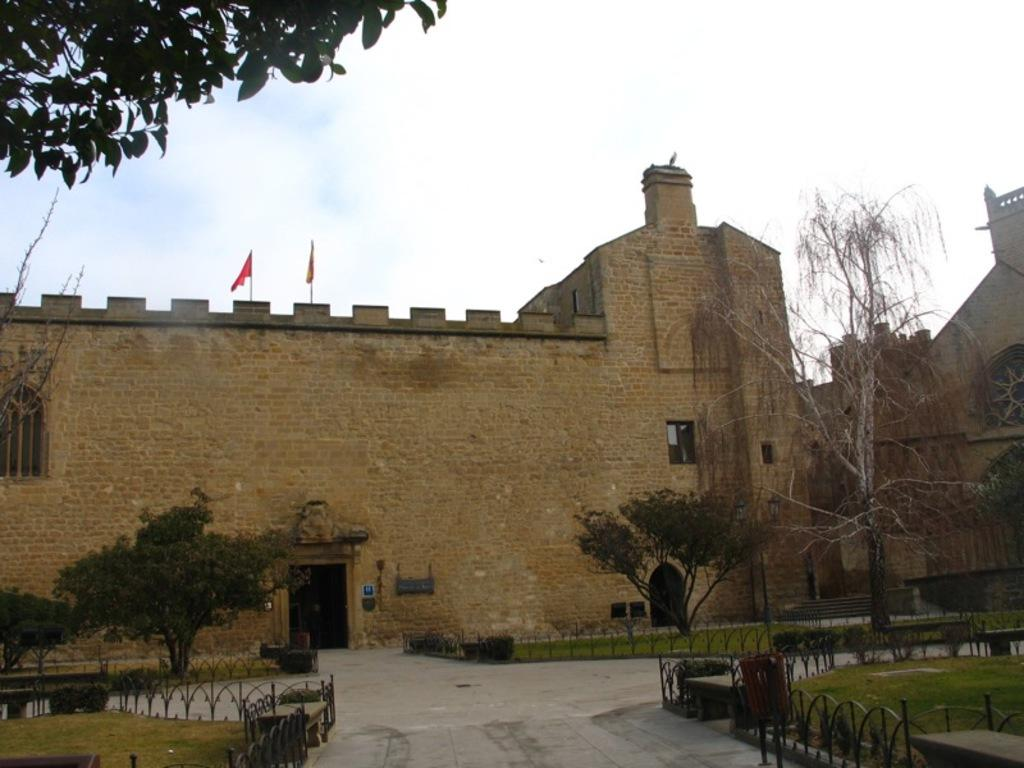What type of vegetation can be seen in the top left corner of the image? There are leaves of a tree in the top left corner of the image. What type of structure is in the middle of the image? There is a brick wall in the middle of the image. What can be seen in the background of the image? The sky is visible in the background of the image. How many books are stacked under the umbrella in the image? There is no umbrella or books present in the image. What grade is the student studying in the image? There is no student or grade mentioned in the image. 